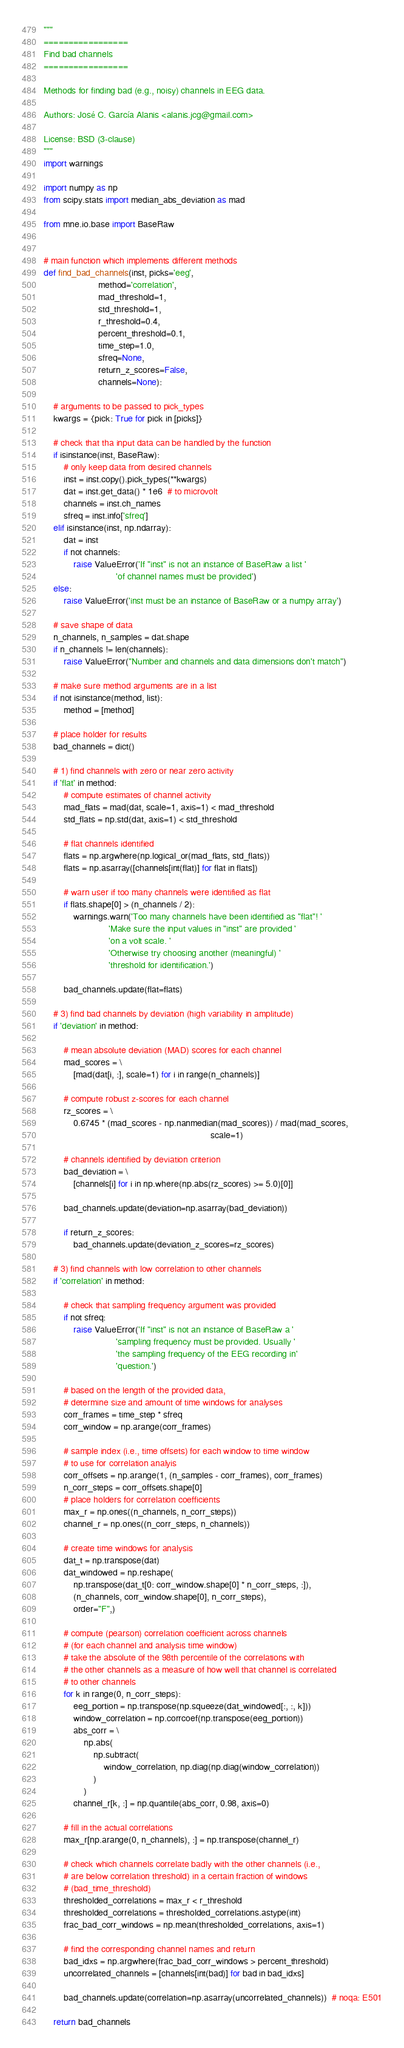Convert code to text. <code><loc_0><loc_0><loc_500><loc_500><_Python_>"""
=================
Find bad channels
=================

Methods for finding bad (e.g., noisy) channels in EEG data.

Authors: José C. García Alanis <alanis.jcg@gmail.com>

License: BSD (3-clause)
"""
import warnings

import numpy as np
from scipy.stats import median_abs_deviation as mad

from mne.io.base import BaseRaw


# main function which implements different methods
def find_bad_channels(inst, picks='eeg',
                      method='correlation',
                      mad_threshold=1,
                      std_threshold=1,
                      r_threshold=0.4,
                      percent_threshold=0.1,
                      time_step=1.0,
                      sfreq=None,
                      return_z_scores=False,
                      channels=None):

    # arguments to be passed to pick_types
    kwargs = {pick: True for pick in [picks]}

    # check that tha input data can be handled by the function
    if isinstance(inst, BaseRaw):
        # only keep data from desired channels
        inst = inst.copy().pick_types(**kwargs)
        dat = inst.get_data() * 1e6  # to microvolt
        channels = inst.ch_names
        sfreq = inst.info['sfreq']
    elif isinstance(inst, np.ndarray):
        dat = inst
        if not channels:
            raise ValueError('If "inst" is not an instance of BaseRaw a list '
                             'of channel names must be provided')
    else:
        raise ValueError('inst must be an instance of BaseRaw or a numpy array')

    # save shape of data
    n_channels, n_samples = dat.shape
    if n_channels != len(channels):
        raise ValueError("Number and channels and data dimensions don't match")

    # make sure method arguments are in a list
    if not isinstance(method, list):
        method = [method]

    # place holder for results
    bad_channels = dict()

    # 1) find channels with zero or near zero activity
    if 'flat' in method:
        # compute estimates of channel activity
        mad_flats = mad(dat, scale=1, axis=1) < mad_threshold
        std_flats = np.std(dat, axis=1) < std_threshold

        # flat channels identified
        flats = np.argwhere(np.logical_or(mad_flats, std_flats))
        flats = np.asarray([channels[int(flat)] for flat in flats])

        # warn user if too many channels were identified as flat
        if flats.shape[0] > (n_channels / 2):
            warnings.warn('Too many channels have been identified as "flat"! '
                          'Make sure the input values in "inst" are provided '
                          'on a volt scale. '
                          'Otherwise try choosing another (meaningful) '
                          'threshold for identification.')

        bad_channels.update(flat=flats)

    # 3) find bad channels by deviation (high variability in amplitude)
    if 'deviation' in method:

        # mean absolute deviation (MAD) scores for each channel
        mad_scores = \
            [mad(dat[i, :], scale=1) for i in range(n_channels)]

        # compute robust z-scores for each channel
        rz_scores = \
            0.6745 * (mad_scores - np.nanmedian(mad_scores)) / mad(mad_scores,
                                                                   scale=1)

        # channels identified by deviation criterion
        bad_deviation = \
            [channels[i] for i in np.where(np.abs(rz_scores) >= 5.0)[0]]

        bad_channels.update(deviation=np.asarray(bad_deviation))

        if return_z_scores:
            bad_channels.update(deviation_z_scores=rz_scores)

    # 3) find channels with low correlation to other channels
    if 'correlation' in method:

        # check that sampling frequency argument was provided
        if not sfreq:
            raise ValueError('If "inst" is not an instance of BaseRaw a '
                             'sampling frequency must be provided. Usually '
                             'the sampling frequency of the EEG recording in'
                             'question.')

        # based on the length of the provided data,
        # determine size and amount of time windows for analyses
        corr_frames = time_step * sfreq
        corr_window = np.arange(corr_frames)

        # sample index (i.e., time offsets) for each window to time window
        # to use for correlation analyis
        corr_offsets = np.arange(1, (n_samples - corr_frames), corr_frames)
        n_corr_steps = corr_offsets.shape[0]
        # place holders for correlation coefficients
        max_r = np.ones((n_channels, n_corr_steps))
        channel_r = np.ones((n_corr_steps, n_channels))

        # create time windows for analysis
        dat_t = np.transpose(dat)
        dat_windowed = np.reshape(
            np.transpose(dat_t[0: corr_window.shape[0] * n_corr_steps, :]),
            (n_channels, corr_window.shape[0], n_corr_steps),
            order="F",)

        # compute (pearson) correlation coefficient across channels
        # (for each channel and analysis time window)
        # take the absolute of the 98th percentile of the correlations with
        # the other channels as a measure of how well that channel is correlated
        # to other channels
        for k in range(0, n_corr_steps):
            eeg_portion = np.transpose(np.squeeze(dat_windowed[:, :, k]))
            window_correlation = np.corrcoef(np.transpose(eeg_portion))
            abs_corr = \
                np.abs(
                    np.subtract(
                        window_correlation, np.diag(np.diag(window_correlation))
                    )
                )
            channel_r[k, :] = np.quantile(abs_corr, 0.98, axis=0)

        # fill in the actual correlations
        max_r[np.arange(0, n_channels), :] = np.transpose(channel_r)

        # check which channels correlate badly with the other channels (i.e.,
        # are below correlation threshold) in a certain fraction of windows
        # (bad_time_threshold)
        thresholded_correlations = max_r < r_threshold
        thresholded_correlations = thresholded_correlations.astype(int)
        frac_bad_corr_windows = np.mean(thresholded_correlations, axis=1)

        # find the corresponding channel names and return
        bad_idxs = np.argwhere(frac_bad_corr_windows > percent_threshold)
        uncorrelated_channels = [channels[int(bad)] for bad in bad_idxs]

        bad_channels.update(correlation=np.asarray(uncorrelated_channels))  # noqa: E501

    return bad_channels
</code> 